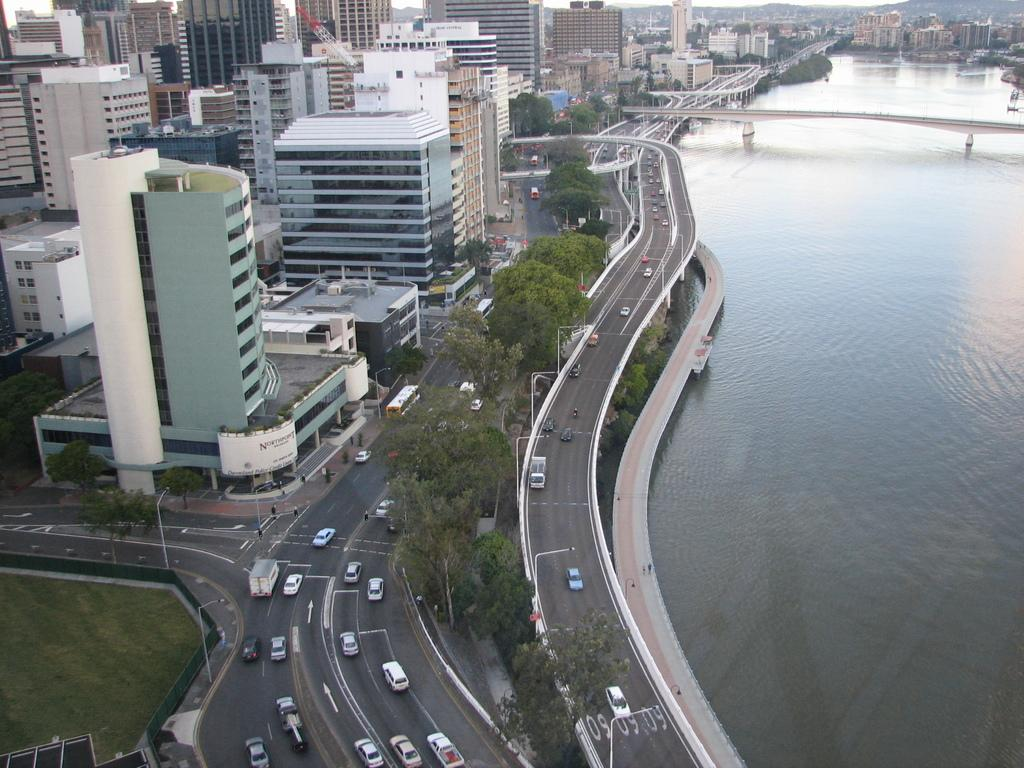What type of structures can be seen in the image? There are buildings in the image. What natural elements are present in the image? There are trees and grass in the image. What man-made elements can be seen in the image? There are vehicles, a road, poles, and a bridge in the image. Is there any water visible in the image? Yes, there is water visible in the image. What type of tray is being used to hold the gold in the image? There is no tray or gold present in the image. How is the glue being used in the image? There is no glue present in the image. 